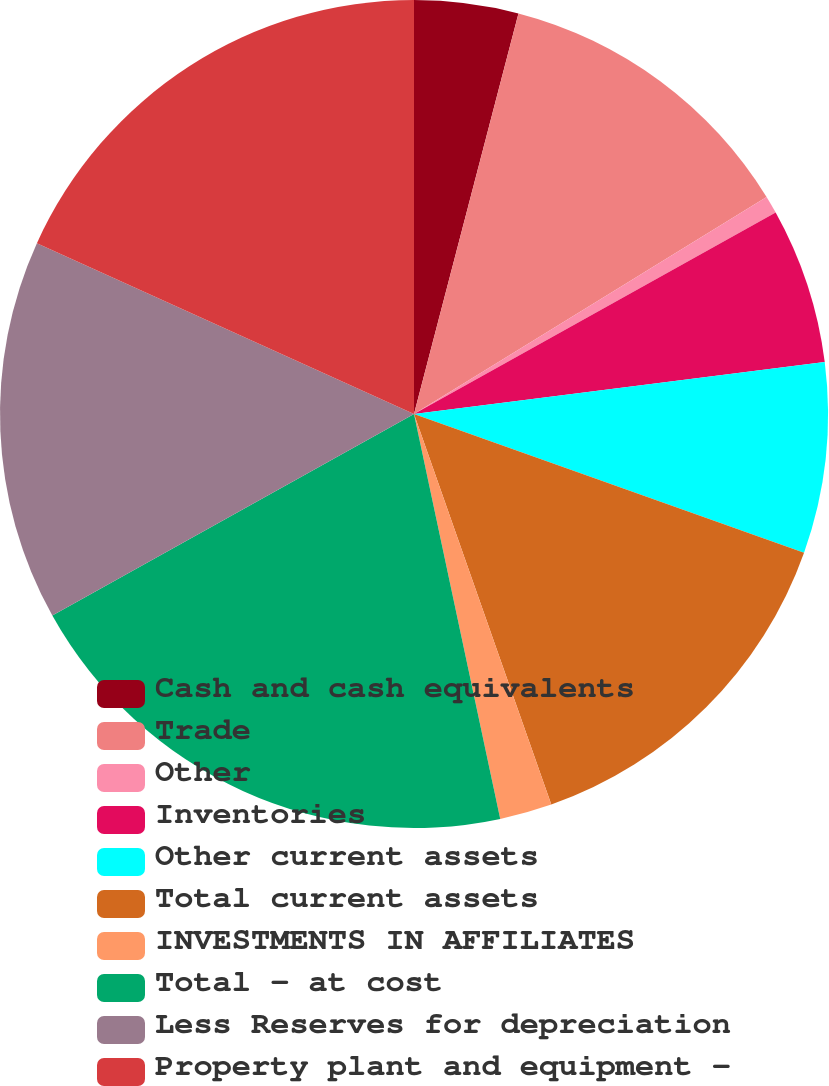Convert chart to OTSL. <chart><loc_0><loc_0><loc_500><loc_500><pie_chart><fcel>Cash and cash equivalents<fcel>Trade<fcel>Other<fcel>Inventories<fcel>Other current assets<fcel>Total current assets<fcel>INVESTMENTS IN AFFILIATES<fcel>Total - at cost<fcel>Less Reserves for depreciation<fcel>Property plant and equipment -<nl><fcel>4.06%<fcel>12.16%<fcel>0.69%<fcel>6.09%<fcel>7.44%<fcel>14.18%<fcel>2.04%<fcel>20.25%<fcel>14.86%<fcel>18.23%<nl></chart> 